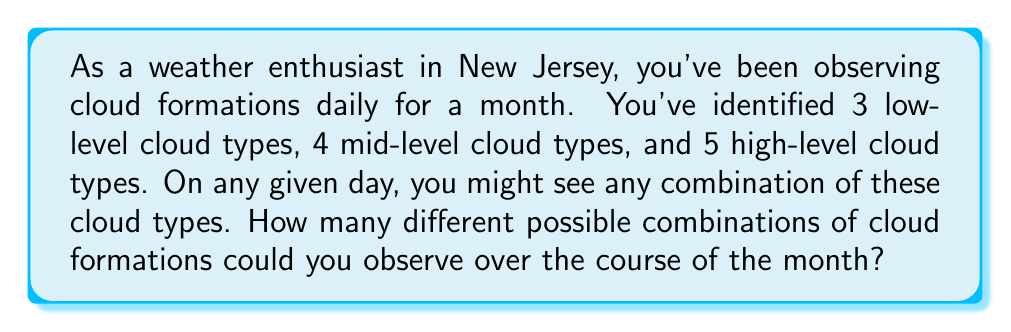Can you solve this math problem? Let's approach this step-by-step:

1) For each level of clouds, we have two options: either we see that type of cloud, or we don't.

2) For low-level clouds:
   - We have 3 types, and each can be present or absent
   - This gives us $2^3 = 8$ possibilities for low-level clouds

3) For mid-level clouds:
   - We have 4 types, each can be present or absent
   - This gives us $2^4 = 16$ possibilities for mid-level clouds

4) For high-level clouds:
   - We have 5 types, each can be present or absent
   - This gives us $2^5 = 32$ possibilities for high-level clouds

5) Now, for each day, we can have any combination of these possibilities:
   - We multiply the number of possibilities for each level
   - Total combinations = $8 \times 16 \times 32$

6) Let's calculate:
   $$ 8 \times 16 \times 32 = 128 \times 32 = 4,096 $$

Therefore, there are 4,096 different possible combinations of cloud formations that could be observed over the course of the month.
Answer: 4,096 